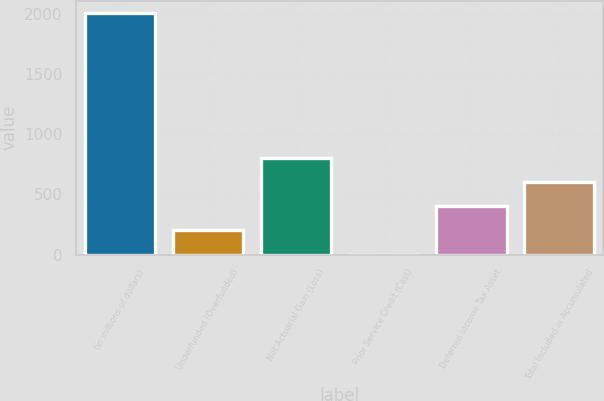Convert chart. <chart><loc_0><loc_0><loc_500><loc_500><bar_chart><fcel>(in millions of dollars)<fcel>Underfunded (Overfunded)<fcel>Net Actuarial Gain (Loss)<fcel>Prior Service Credit (Cost)<fcel>Deferred Income Tax Asset<fcel>Total Included in Accumulated<nl><fcel>2010<fcel>201.27<fcel>804.18<fcel>0.3<fcel>402.24<fcel>603.21<nl></chart> 